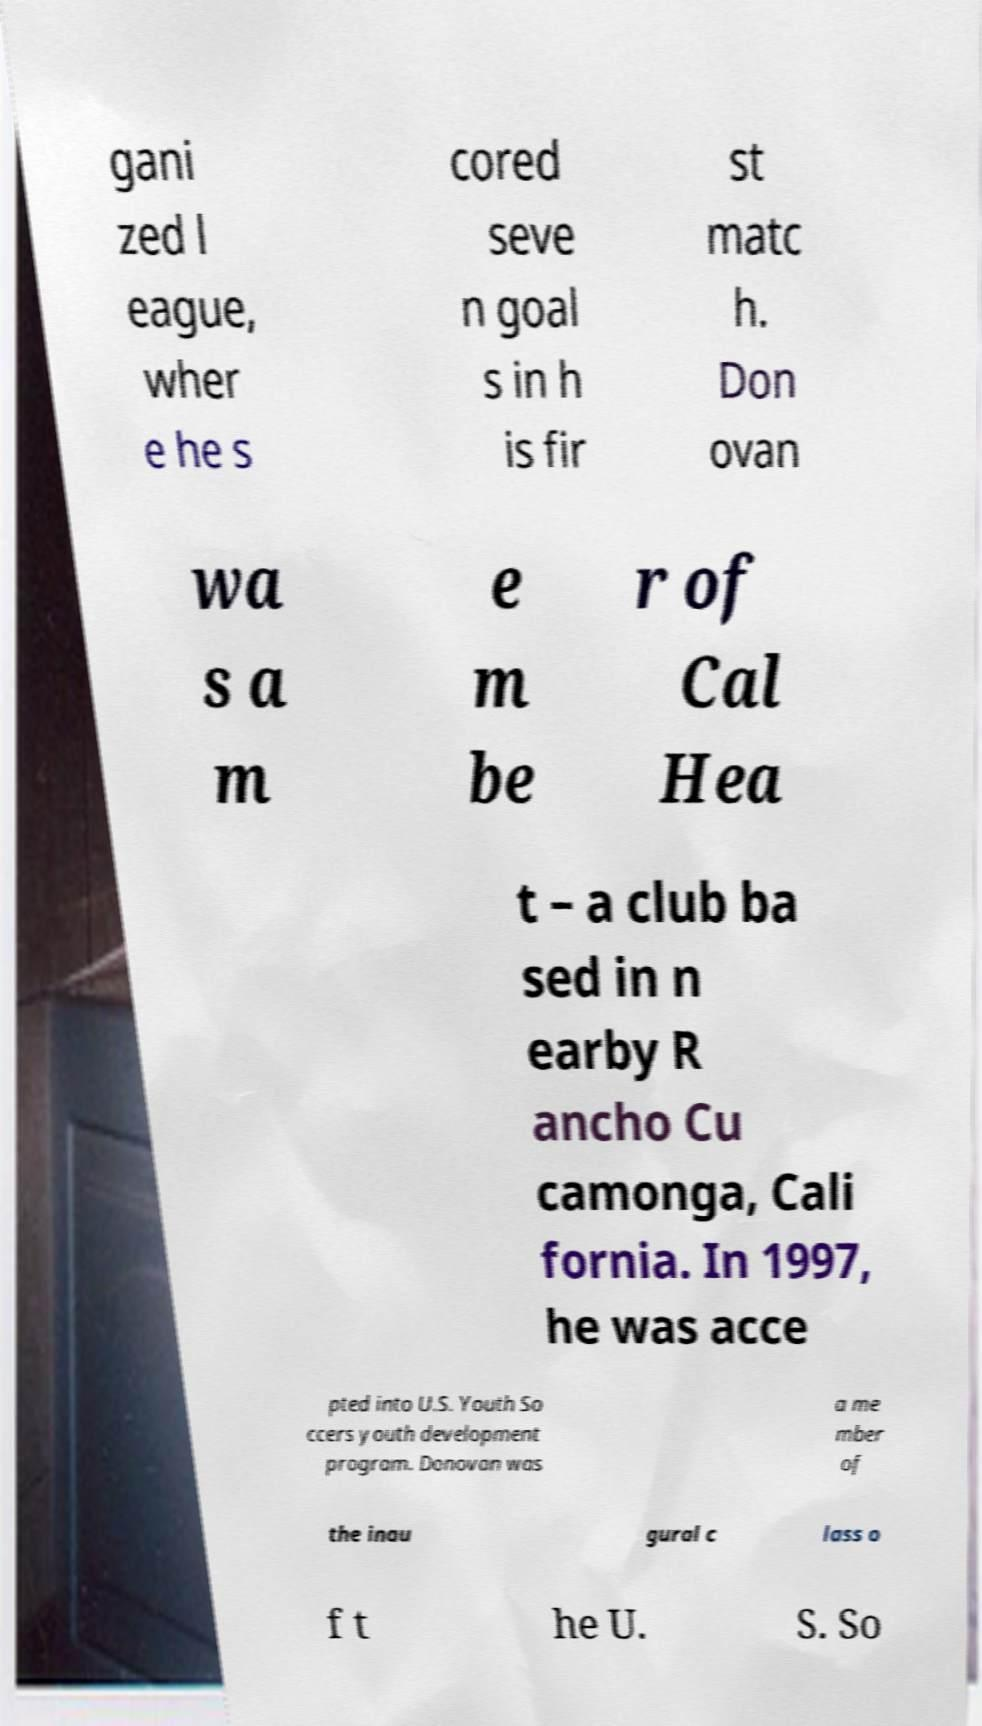What messages or text are displayed in this image? I need them in a readable, typed format. gani zed l eague, wher e he s cored seve n goal s in h is fir st matc h. Don ovan wa s a m e m be r of Cal Hea t – a club ba sed in n earby R ancho Cu camonga, Cali fornia. In 1997, he was acce pted into U.S. Youth So ccers youth development program. Donovan was a me mber of the inau gural c lass o f t he U. S. So 